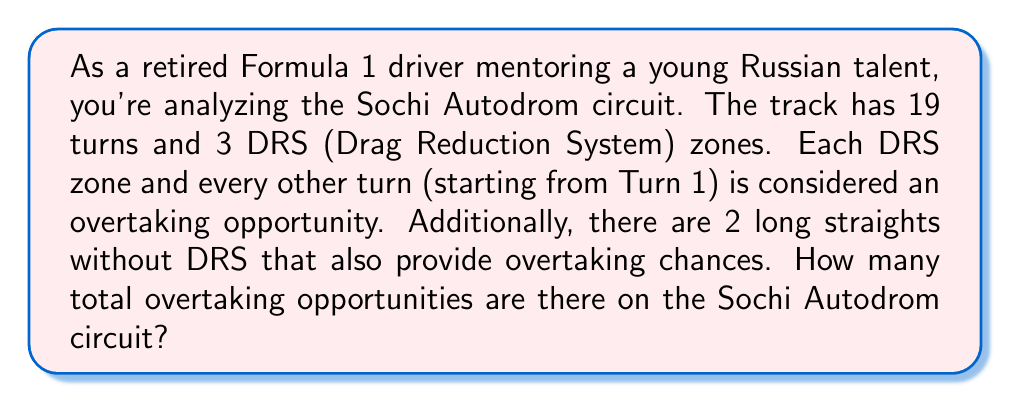Help me with this question. Let's break this problem down step by step:

1. DRS zones:
   There are 3 DRS zones, each providing an overtaking opportunity.
   $$\text{DRS opportunities} = 3$$

2. Turns:
   There are 19 turns in total, but only every other turn (starting from Turn 1) is considered an overtaking opportunity.
   To calculate this, we can use the formula for the number of integers in an arithmetic sequence:
   $$n = \left\lfloor\frac{\text{last term} - \text{first term}}{\text{step size}}\right\rfloor + 1$$
   Where $\lfloor \cdot \rfloor$ denotes the floor function.
   
   In this case:
   $$n = \left\lfloor\frac{19 - 1}{2}\right\rfloor + 1 = \lfloor 9 \rfloor + 1 = 10$$

   So, there are 10 turns that provide overtaking opportunities.

3. Long straights without DRS:
   There are 2 additional long straights that provide overtaking chances.

4. Total overtaking opportunities:
   To get the total, we sum up all the opportunities:
   $$\text{Total} = \text{DRS} + \text{Turns} + \text{Long straights}$$
   $$\text{Total} = 3 + 10 + 2 = 15$$

Therefore, there are 15 total overtaking opportunities on the Sochi Autodrom circuit.
Answer: 15 overtaking opportunities 